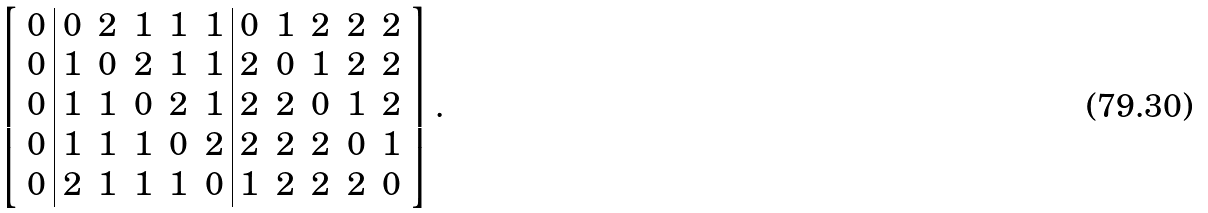<formula> <loc_0><loc_0><loc_500><loc_500>\left [ \begin{array} { c | c c c c c | c c c c c } 0 & 0 & 2 & 1 & 1 & 1 & 0 & 1 & 2 & 2 & 2 \\ 0 & 1 & 0 & 2 & 1 & 1 & 2 & 0 & 1 & 2 & 2 \\ 0 & 1 & 1 & 0 & 2 & 1 & 2 & 2 & 0 & 1 & 2 \\ 0 & 1 & 1 & 1 & 0 & 2 & 2 & 2 & 2 & 0 & 1 \\ 0 & 2 & 1 & 1 & 1 & 0 & 1 & 2 & 2 & 2 & 0 \\ \end{array} \right ] .</formula> 